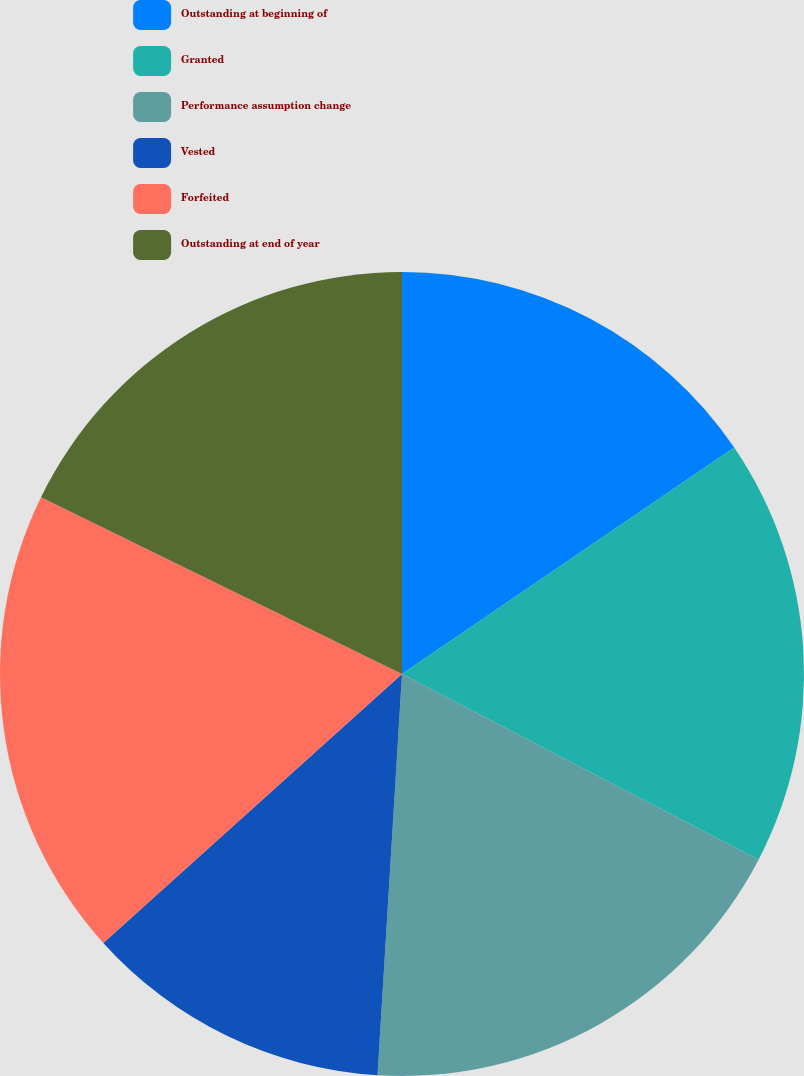Convert chart to OTSL. <chart><loc_0><loc_0><loc_500><loc_500><pie_chart><fcel>Outstanding at beginning of<fcel>Granted<fcel>Performance assumption change<fcel>Vested<fcel>Forfeited<fcel>Outstanding at end of year<nl><fcel>15.48%<fcel>17.16%<fcel>18.33%<fcel>12.36%<fcel>18.92%<fcel>17.75%<nl></chart> 